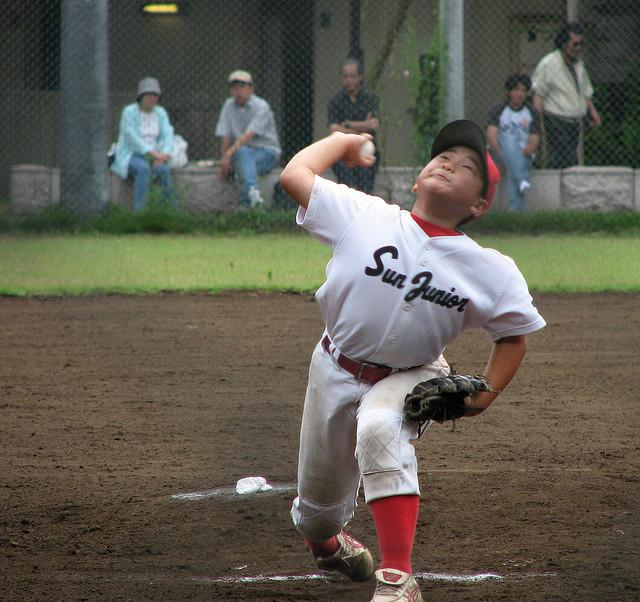Where in the world is this being played? china 